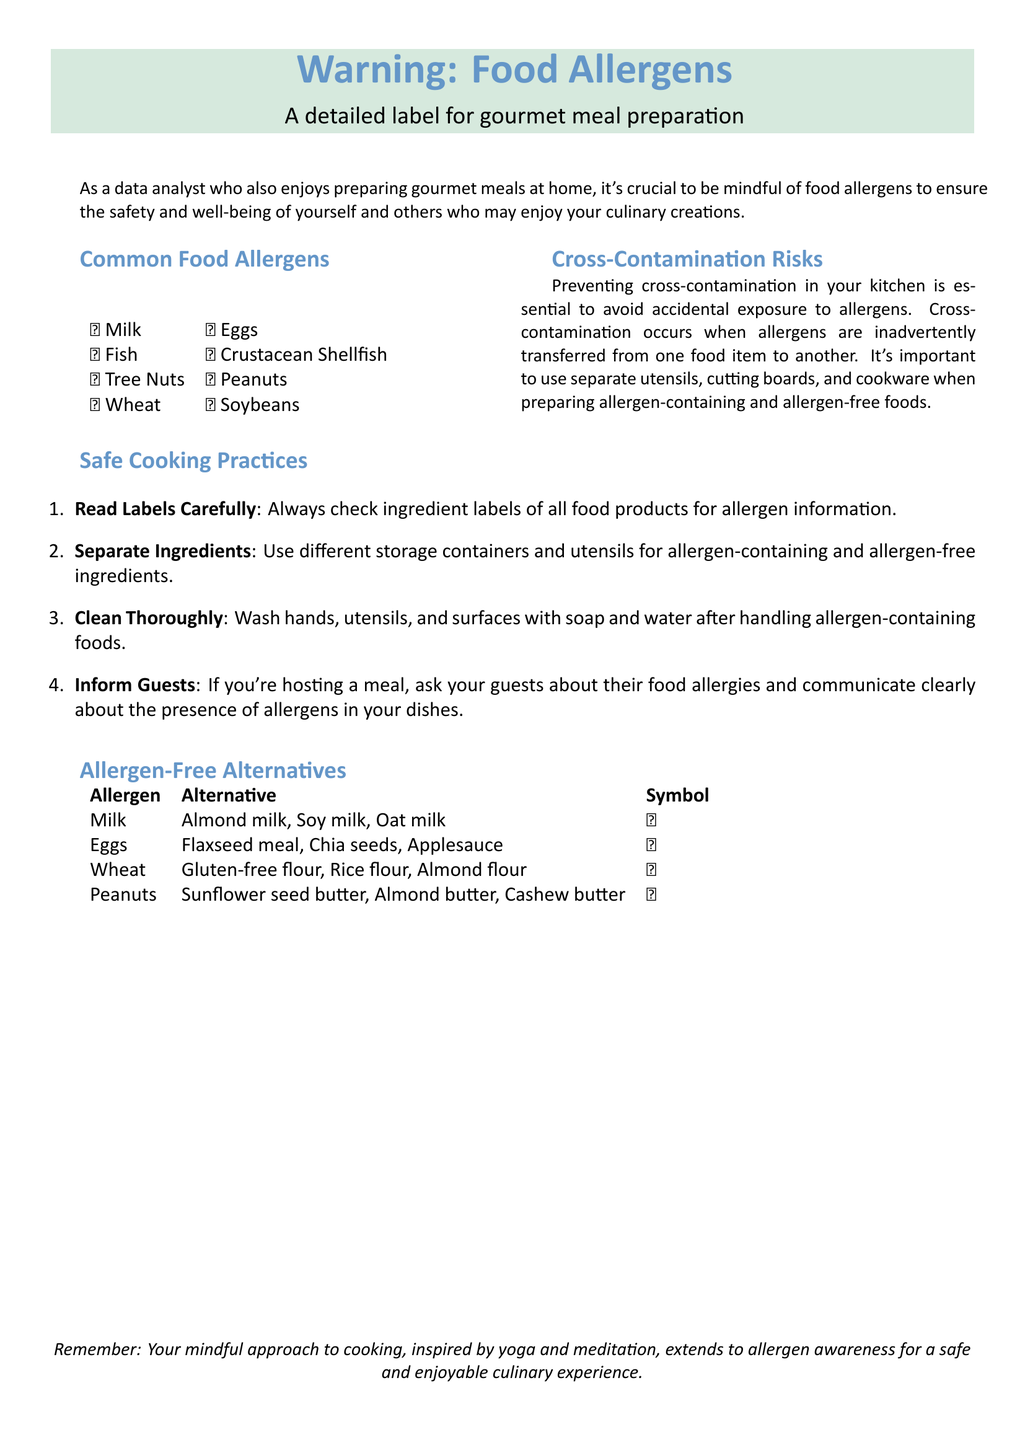What is the main purpose of this label? The label aims to ensure safety and well-being regarding food allergens for gourmet meal preparation.
Answer: Safety and well-being How many common food allergens are listed? There are 8 common food allergens mentioned in the document.
Answer: 8 Which allergen has a symbol of a sunflower? The document lists sunflower seed butter as an alternative to one allergen, which is peanuts.
Answer: Peanuts What should be used for allergen-free flour? The label suggests gluten-free flour, rice flour, and almond flour as alternatives for wheat.
Answer: Gluten-free flour, rice flour, almond flour What is one of the safe cooking practices mentioned? The document emphasizes reading labels carefully as an important safe cooking practice.
Answer: Read Labels Carefully How should utensils be managed to prevent cross-contamination? The document specifies using separate utensils for allergen-containing and allergen-free foods.
Answer: Separate utensils What symbol indicates allergen-free alternatives? The document includes specific symbols for allergen-free alternatives, with 🌿 representing milk alternates.
Answer: 🌿 What is the first common food allergen listed? The first allergen listed is milk, as indicated in the document.
Answer: Milk 